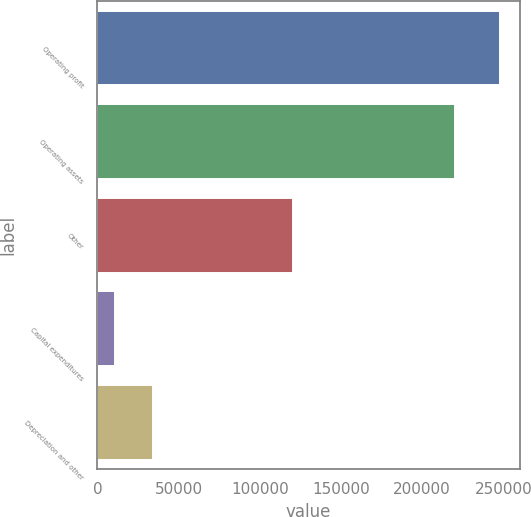<chart> <loc_0><loc_0><loc_500><loc_500><bar_chart><fcel>Operating profit<fcel>Operating assets<fcel>Other<fcel>Capital expenditures<fcel>Depreciation and other<nl><fcel>247596<fcel>220115<fcel>120681<fcel>10713<fcel>34401.3<nl></chart> 